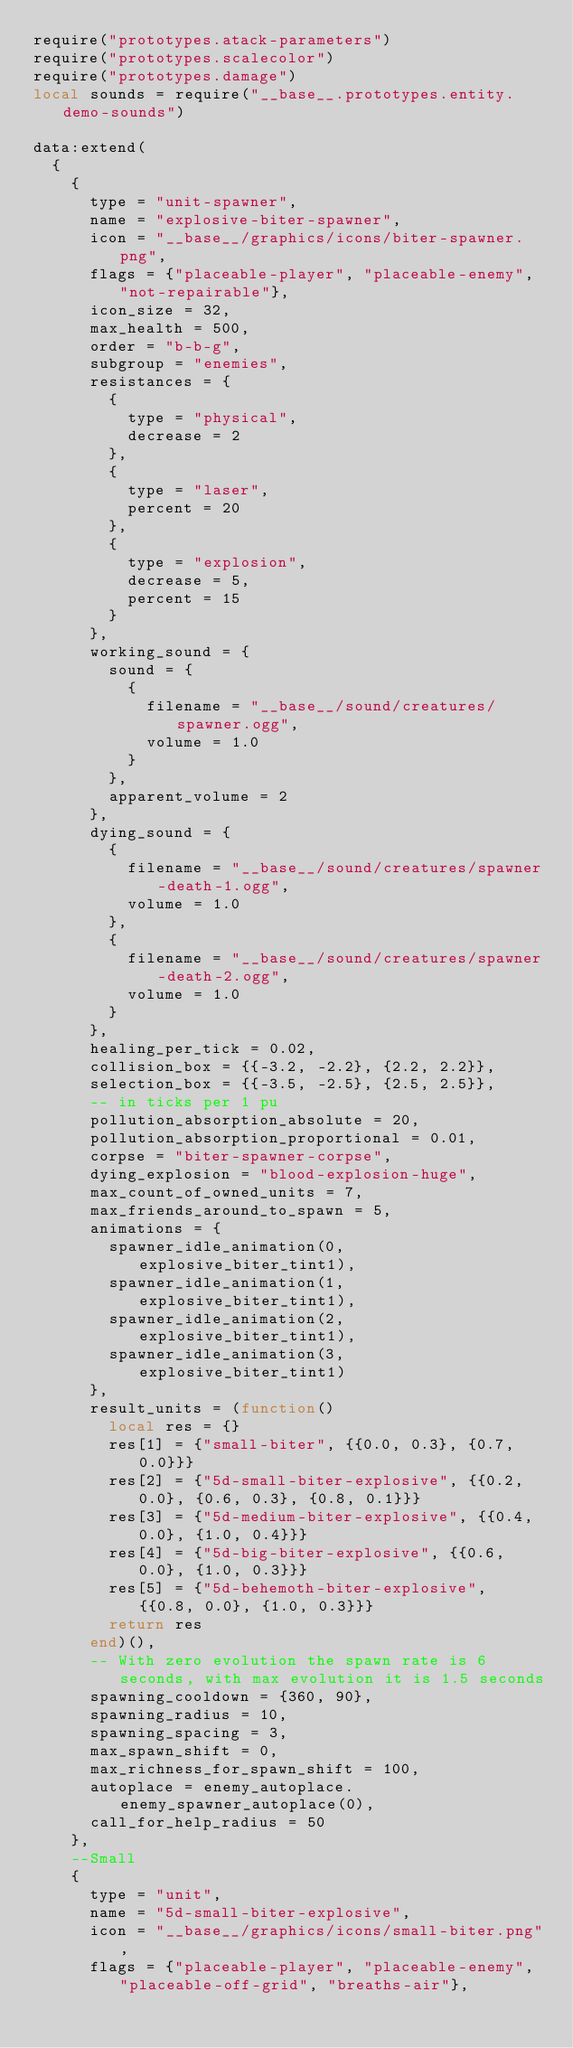Convert code to text. <code><loc_0><loc_0><loc_500><loc_500><_Lua_>require("prototypes.atack-parameters")
require("prototypes.scalecolor")
require("prototypes.damage")
local sounds = require("__base__.prototypes.entity.demo-sounds")

data:extend(
  {
    {
      type = "unit-spawner",
      name = "explosive-biter-spawner",
      icon = "__base__/graphics/icons/biter-spawner.png",
      flags = {"placeable-player", "placeable-enemy", "not-repairable"},
      icon_size = 32,
      max_health = 500,
      order = "b-b-g",
      subgroup = "enemies",
      resistances = {
        {
          type = "physical",
          decrease = 2
        },
        {
          type = "laser",
          percent = 20
        },
        {
          type = "explosion",
          decrease = 5,
          percent = 15
        }
      },
      working_sound = {
        sound = {
          {
            filename = "__base__/sound/creatures/spawner.ogg",
            volume = 1.0
          }
        },
        apparent_volume = 2
      },
      dying_sound = {
        {
          filename = "__base__/sound/creatures/spawner-death-1.ogg",
          volume = 1.0
        },
        {
          filename = "__base__/sound/creatures/spawner-death-2.ogg",
          volume = 1.0
        }
      },
      healing_per_tick = 0.02,
      collision_box = {{-3.2, -2.2}, {2.2, 2.2}},
      selection_box = {{-3.5, -2.5}, {2.5, 2.5}},
      -- in ticks per 1 pu
      pollution_absorption_absolute = 20,
      pollution_absorption_proportional = 0.01,
      corpse = "biter-spawner-corpse",
      dying_explosion = "blood-explosion-huge",
      max_count_of_owned_units = 7,
      max_friends_around_to_spawn = 5,
      animations = {
        spawner_idle_animation(0, explosive_biter_tint1),
        spawner_idle_animation(1, explosive_biter_tint1),
        spawner_idle_animation(2, explosive_biter_tint1),
        spawner_idle_animation(3, explosive_biter_tint1)
      },
      result_units = (function()
        local res = {}
        res[1] = {"small-biter", {{0.0, 0.3}, {0.7, 0.0}}}
        res[2] = {"5d-small-biter-explosive", {{0.2, 0.0}, {0.6, 0.3}, {0.8, 0.1}}}
        res[3] = {"5d-medium-biter-explosive", {{0.4, 0.0}, {1.0, 0.4}}}
        res[4] = {"5d-big-biter-explosive", {{0.6, 0.0}, {1.0, 0.3}}}
        res[5] = {"5d-behemoth-biter-explosive", {{0.8, 0.0}, {1.0, 0.3}}}
        return res
      end)(),
      -- With zero evolution the spawn rate is 6 seconds, with max evolution it is 1.5 seconds
      spawning_cooldown = {360, 90},
      spawning_radius = 10,
      spawning_spacing = 3,
      max_spawn_shift = 0,
      max_richness_for_spawn_shift = 100,
      autoplace = enemy_autoplace.enemy_spawner_autoplace(0),
      call_for_help_radius = 50
    },
    --Small
    {
      type = "unit",
      name = "5d-small-biter-explosive",
      icon = "__base__/graphics/icons/small-biter.png",
      flags = {"placeable-player", "placeable-enemy", "placeable-off-grid", "breaths-air"},</code> 